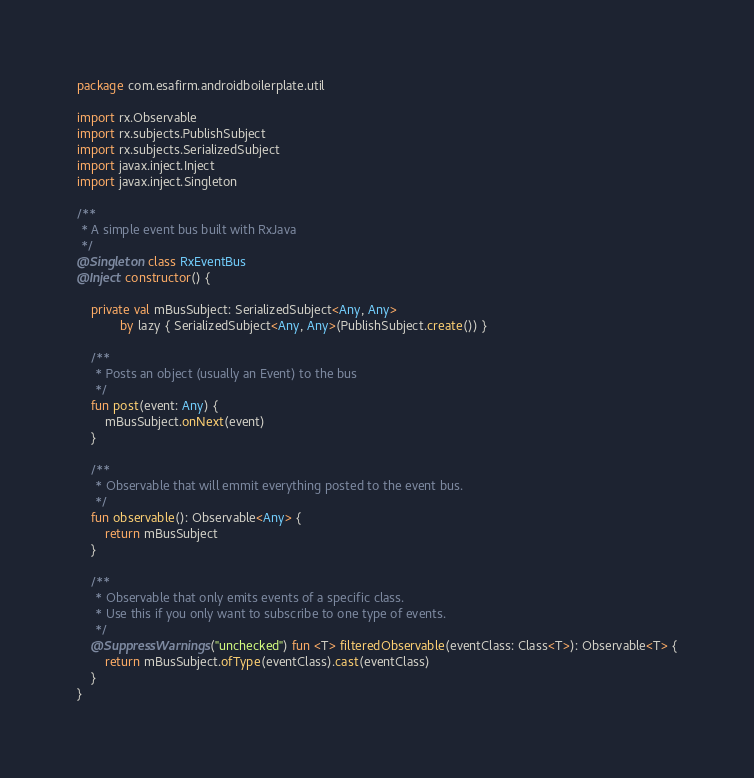Convert code to text. <code><loc_0><loc_0><loc_500><loc_500><_Kotlin_>package com.esafirm.androidboilerplate.util

import rx.Observable
import rx.subjects.PublishSubject
import rx.subjects.SerializedSubject
import javax.inject.Inject
import javax.inject.Singleton

/**
 * A simple event bus built with RxJava
 */
@Singleton class RxEventBus
@Inject constructor() {

	private val mBusSubject: SerializedSubject<Any, Any>
			by lazy { SerializedSubject<Any, Any>(PublishSubject.create()) }

	/**
	 * Posts an object (usually an Event) to the bus
	 */
	fun post(event: Any) {
		mBusSubject.onNext(event)
	}

	/**
	 * Observable that will emmit everything posted to the event bus.
	 */
	fun observable(): Observable<Any> {
		return mBusSubject
	}

	/**
	 * Observable that only emits events of a specific class.
	 * Use this if you only want to subscribe to one type of events.
	 */
	@SuppressWarnings("unchecked") fun <T> filteredObservable(eventClass: Class<T>): Observable<T> {
		return mBusSubject.ofType(eventClass).cast(eventClass)
	}
}
</code> 